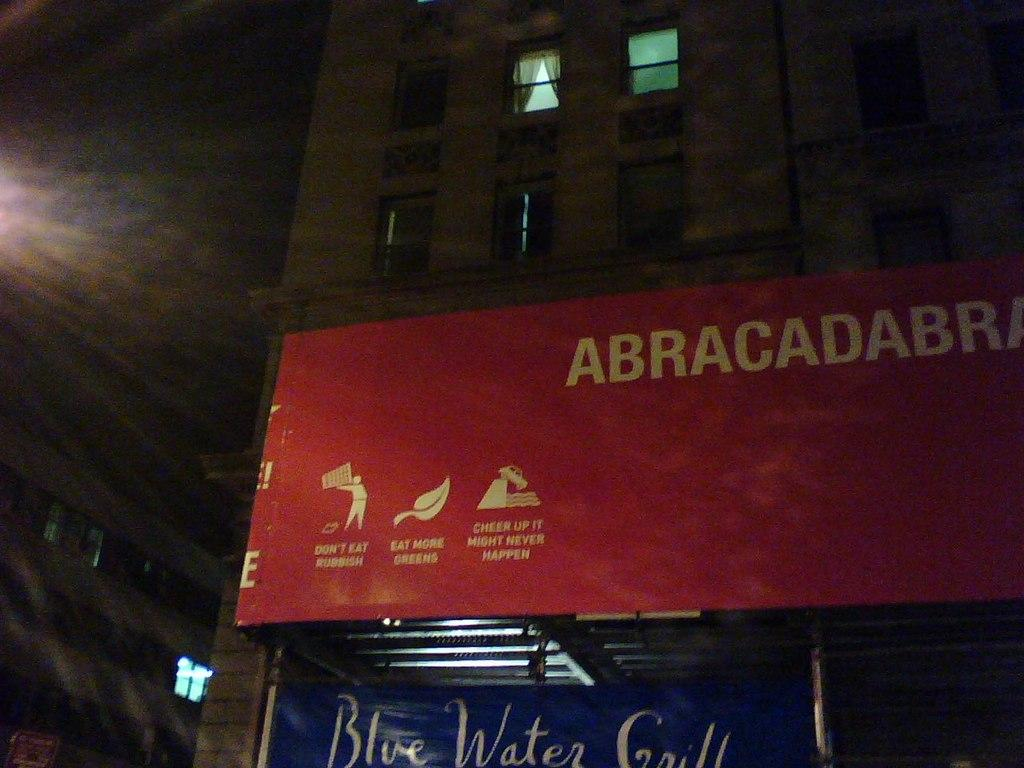<image>
Provide a brief description of the given image. A red banner on which is written: ABRACADABRA 